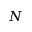Convert formula to latex. <formula><loc_0><loc_0><loc_500><loc_500>N</formula> 